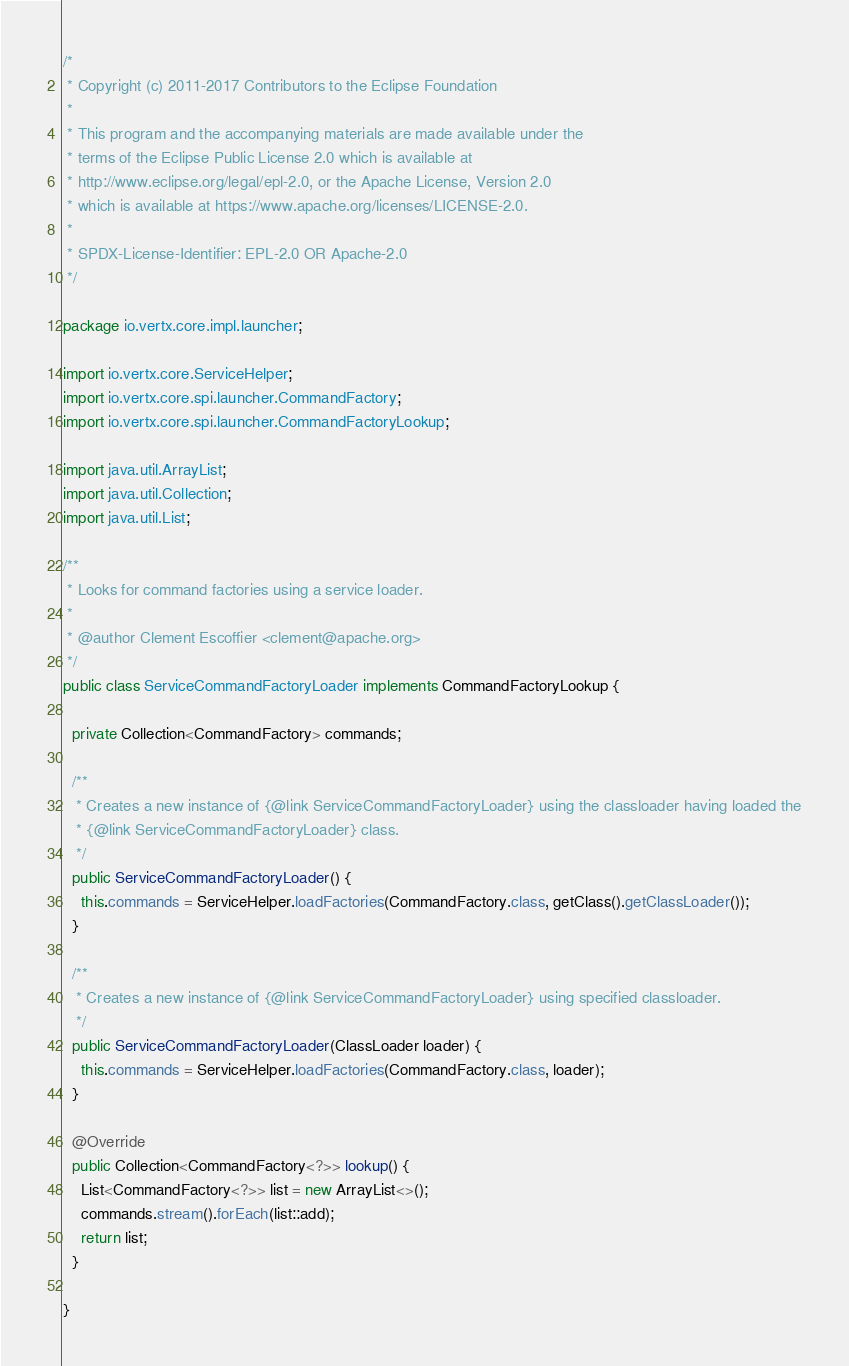<code> <loc_0><loc_0><loc_500><loc_500><_Java_>/*
 * Copyright (c) 2011-2017 Contributors to the Eclipse Foundation
 *
 * This program and the accompanying materials are made available under the
 * terms of the Eclipse Public License 2.0 which is available at
 * http://www.eclipse.org/legal/epl-2.0, or the Apache License, Version 2.0
 * which is available at https://www.apache.org/licenses/LICENSE-2.0.
 *
 * SPDX-License-Identifier: EPL-2.0 OR Apache-2.0
 */

package io.vertx.core.impl.launcher;

import io.vertx.core.ServiceHelper;
import io.vertx.core.spi.launcher.CommandFactory;
import io.vertx.core.spi.launcher.CommandFactoryLookup;

import java.util.ArrayList;
import java.util.Collection;
import java.util.List;

/**
 * Looks for command factories using a service loader.
 *
 * @author Clement Escoffier <clement@apache.org>
 */
public class ServiceCommandFactoryLoader implements CommandFactoryLookup {

  private Collection<CommandFactory> commands;

  /**
   * Creates a new instance of {@link ServiceCommandFactoryLoader} using the classloader having loaded the
   * {@link ServiceCommandFactoryLoader} class.
   */
  public ServiceCommandFactoryLoader() {
    this.commands = ServiceHelper.loadFactories(CommandFactory.class, getClass().getClassLoader());
  }

  /**
   * Creates a new instance of {@link ServiceCommandFactoryLoader} using specified classloader.
   */
  public ServiceCommandFactoryLoader(ClassLoader loader) {
    this.commands = ServiceHelper.loadFactories(CommandFactory.class, loader);
  }

  @Override
  public Collection<CommandFactory<?>> lookup() {
    List<CommandFactory<?>> list = new ArrayList<>();
    commands.stream().forEach(list::add);
    return list;
  }

}
</code> 